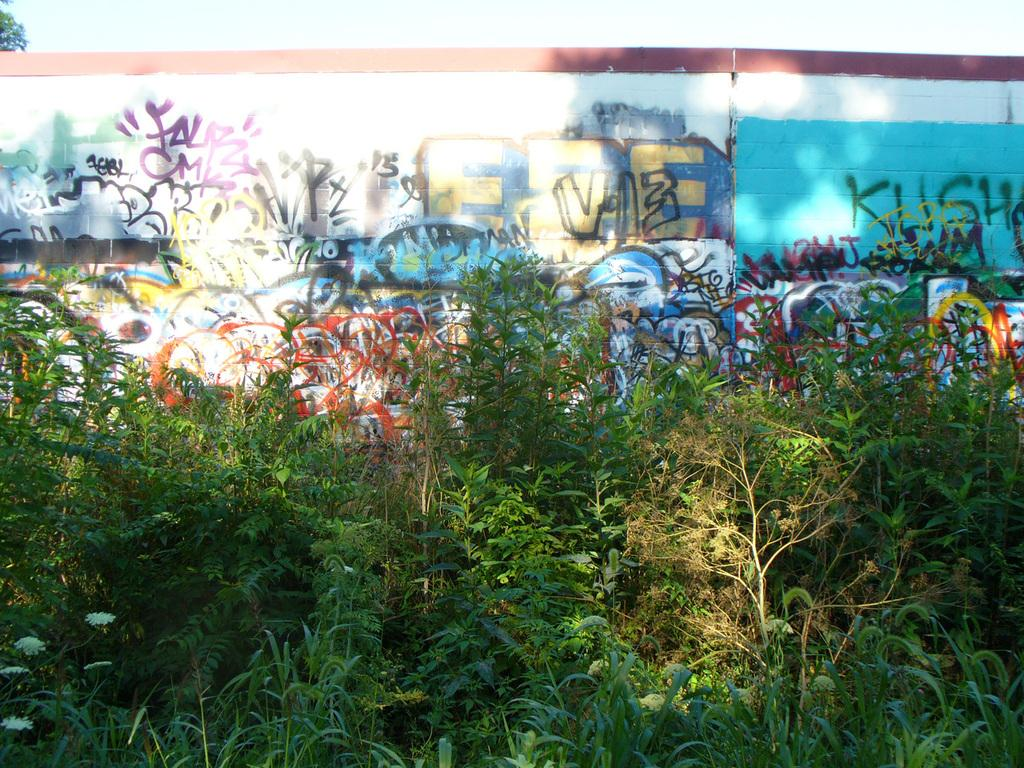What type of living organisms can be seen in the image? Plants can be seen in the image. What is the color of the plants in the image? The plants are green. What is visible in the background of the image? There is a wall and the sky visible in the background of the image. How many colors can be seen on the wall in the image? The wall has multiple colors. What is the color of the sky in the image? The color of the sky is white. What type of liquid is being used to paint the canvas in the image? There is no canvas or liquid present in the image. What flavor of toothpaste is visible on the wall in the image? There is no toothpaste present in the image. 